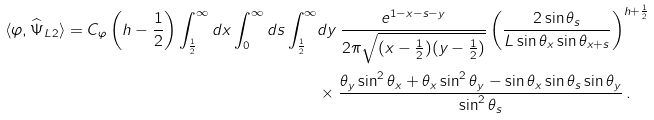<formula> <loc_0><loc_0><loc_500><loc_500>\langle \varphi , \widehat { \Psi } _ { L 2 } \rangle = C _ { \varphi } \left ( h - \frac { 1 } { 2 } \right ) \int _ { \frac { 1 } { 2 } } ^ { \infty } d x \int _ { 0 } ^ { \infty } d s \int _ { \frac { 1 } { 2 } } ^ { \infty } & d y \, \frac { e ^ { 1 - x - s - y } } { 2 \pi \sqrt { ( x - \frac { 1 } { 2 } ) ( y - \frac { 1 } { 2 } ) } } \left ( \frac { 2 \sin \theta _ { s } } { L \sin \theta _ { x } \sin \theta _ { x + s } } \right ) ^ { h + \frac { 1 } { 2 } } \\ & \times \frac { \theta _ { y } \sin ^ { 2 } \theta _ { x } + \theta _ { x } \sin ^ { 2 } \theta _ { y } - \sin \theta _ { x } \sin \theta _ { s } \sin \theta _ { y } } { \sin ^ { 2 } \theta _ { s } } \, .</formula> 